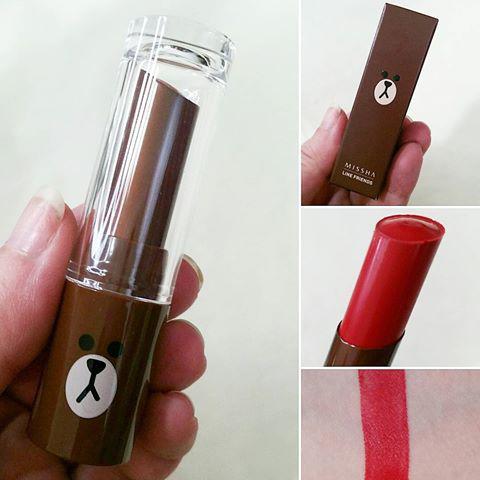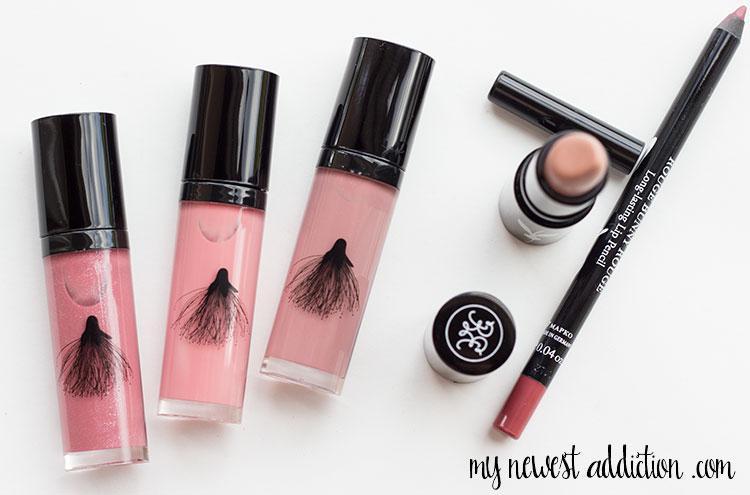The first image is the image on the left, the second image is the image on the right. For the images shown, is this caption "An image contains lip tints in little champagne bottles." true? Answer yes or no. No. 